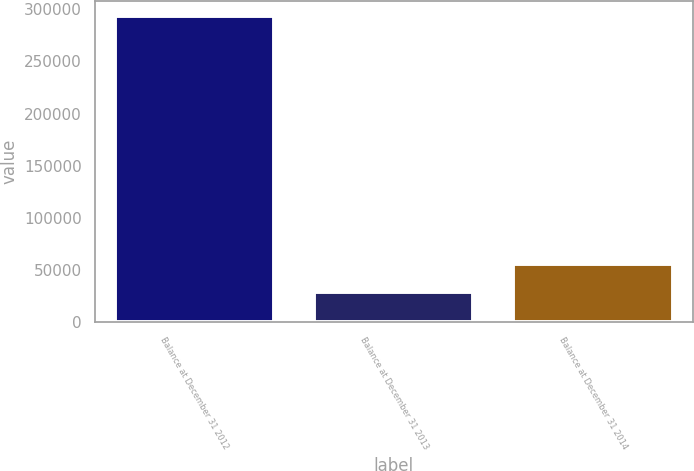Convert chart. <chart><loc_0><loc_0><loc_500><loc_500><bar_chart><fcel>Balance at December 31 2012<fcel>Balance at December 31 2013<fcel>Balance at December 31 2014<nl><fcel>293083<fcel>29324<fcel>55699.9<nl></chart> 